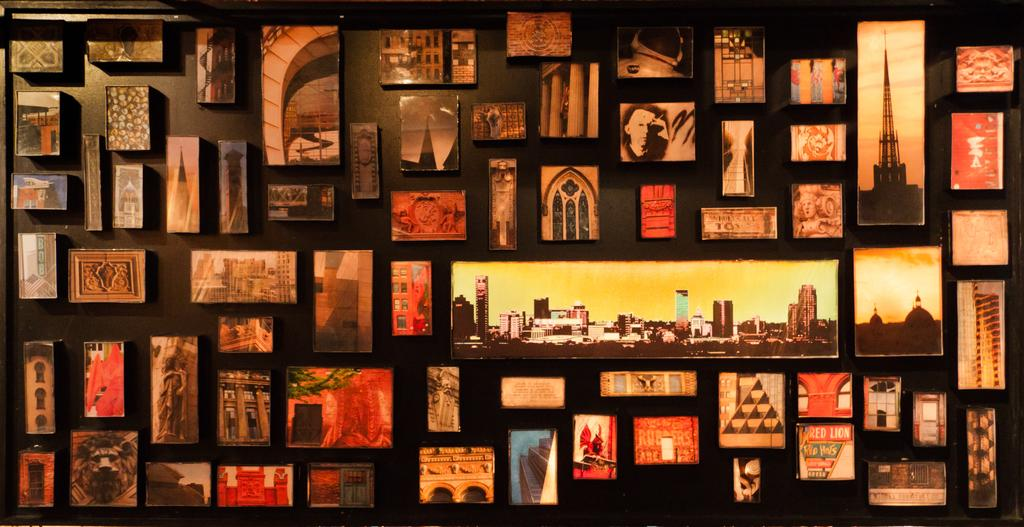What objects can be seen in the image? There are photo frames in the image. Where are the photo frames located? The photo frames are on a wall. What type of ink is used in the photo frames in the image? There is no information about the type of ink used in the photo frames in the image. Can you see any ghosts interacting with the photo frames in the image? There are no ghosts present in the image. 